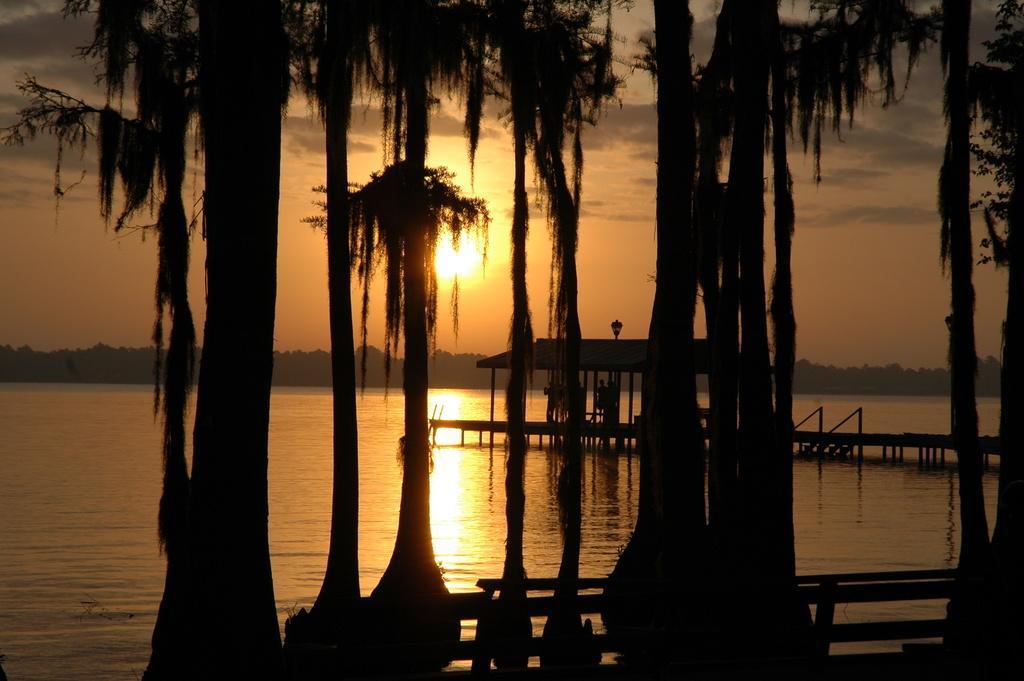Please provide a concise description of this image. This is an outside view. In the foreground there are many trees. At the bottom there is a fencing. In the background there is a sea and also I can see a bridge in the water. In the background there are many trees and also I can see the sky along with the sun. This is an evening view. 